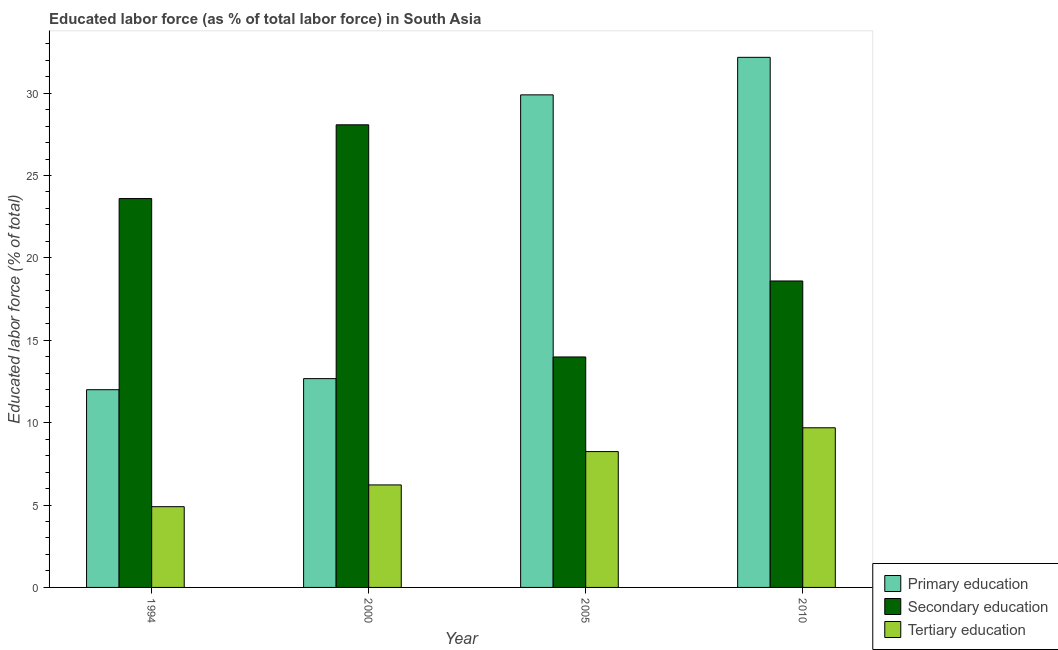How many different coloured bars are there?
Your response must be concise. 3. How many groups of bars are there?
Provide a succinct answer. 4. Are the number of bars per tick equal to the number of legend labels?
Ensure brevity in your answer.  Yes. Are the number of bars on each tick of the X-axis equal?
Your response must be concise. Yes. What is the label of the 4th group of bars from the left?
Ensure brevity in your answer.  2010. What is the percentage of labor force who received secondary education in 1994?
Offer a very short reply. 23.6. Across all years, what is the maximum percentage of labor force who received tertiary education?
Keep it short and to the point. 9.69. Across all years, what is the minimum percentage of labor force who received secondary education?
Provide a succinct answer. 13.99. What is the total percentage of labor force who received secondary education in the graph?
Offer a terse response. 84.26. What is the difference between the percentage of labor force who received primary education in 2005 and that in 2010?
Your response must be concise. -2.28. What is the difference between the percentage of labor force who received primary education in 2010 and the percentage of labor force who received secondary education in 2005?
Provide a short and direct response. 2.28. What is the average percentage of labor force who received tertiary education per year?
Give a very brief answer. 7.26. In how many years, is the percentage of labor force who received tertiary education greater than 30 %?
Provide a succinct answer. 0. What is the ratio of the percentage of labor force who received secondary education in 1994 to that in 2000?
Provide a succinct answer. 0.84. Is the percentage of labor force who received primary education in 1994 less than that in 2000?
Offer a terse response. Yes. What is the difference between the highest and the second highest percentage of labor force who received secondary education?
Give a very brief answer. 4.48. What is the difference between the highest and the lowest percentage of labor force who received secondary education?
Ensure brevity in your answer.  14.09. In how many years, is the percentage of labor force who received primary education greater than the average percentage of labor force who received primary education taken over all years?
Your answer should be very brief. 2. Is the sum of the percentage of labor force who received primary education in 2000 and 2010 greater than the maximum percentage of labor force who received tertiary education across all years?
Your answer should be very brief. Yes. What does the 2nd bar from the left in 2005 represents?
Give a very brief answer. Secondary education. What does the 2nd bar from the right in 2000 represents?
Keep it short and to the point. Secondary education. Is it the case that in every year, the sum of the percentage of labor force who received primary education and percentage of labor force who received secondary education is greater than the percentage of labor force who received tertiary education?
Provide a succinct answer. Yes. How many bars are there?
Give a very brief answer. 12. Does the graph contain grids?
Your answer should be compact. No. What is the title of the graph?
Provide a succinct answer. Educated labor force (as % of total labor force) in South Asia. What is the label or title of the X-axis?
Your response must be concise. Year. What is the label or title of the Y-axis?
Give a very brief answer. Educated labor force (% of total). What is the Educated labor force (% of total) in Secondary education in 1994?
Make the answer very short. 23.6. What is the Educated labor force (% of total) in Tertiary education in 1994?
Your answer should be very brief. 4.9. What is the Educated labor force (% of total) of Primary education in 2000?
Keep it short and to the point. 12.67. What is the Educated labor force (% of total) in Secondary education in 2000?
Your answer should be very brief. 28.08. What is the Educated labor force (% of total) in Tertiary education in 2000?
Offer a very short reply. 6.22. What is the Educated labor force (% of total) in Primary education in 2005?
Your response must be concise. 29.89. What is the Educated labor force (% of total) of Secondary education in 2005?
Provide a succinct answer. 13.99. What is the Educated labor force (% of total) of Tertiary education in 2005?
Offer a very short reply. 8.24. What is the Educated labor force (% of total) of Primary education in 2010?
Your answer should be very brief. 32.17. What is the Educated labor force (% of total) of Secondary education in 2010?
Offer a terse response. 18.6. What is the Educated labor force (% of total) in Tertiary education in 2010?
Your response must be concise. 9.69. Across all years, what is the maximum Educated labor force (% of total) in Primary education?
Provide a succinct answer. 32.17. Across all years, what is the maximum Educated labor force (% of total) in Secondary education?
Provide a short and direct response. 28.08. Across all years, what is the maximum Educated labor force (% of total) of Tertiary education?
Ensure brevity in your answer.  9.69. Across all years, what is the minimum Educated labor force (% of total) of Primary education?
Your answer should be very brief. 12. Across all years, what is the minimum Educated labor force (% of total) of Secondary education?
Your answer should be compact. 13.99. Across all years, what is the minimum Educated labor force (% of total) of Tertiary education?
Your answer should be very brief. 4.9. What is the total Educated labor force (% of total) in Primary education in the graph?
Your answer should be very brief. 86.74. What is the total Educated labor force (% of total) of Secondary education in the graph?
Provide a short and direct response. 84.26. What is the total Educated labor force (% of total) of Tertiary education in the graph?
Offer a very short reply. 29.05. What is the difference between the Educated labor force (% of total) in Primary education in 1994 and that in 2000?
Your answer should be very brief. -0.67. What is the difference between the Educated labor force (% of total) in Secondary education in 1994 and that in 2000?
Your answer should be very brief. -4.48. What is the difference between the Educated labor force (% of total) in Tertiary education in 1994 and that in 2000?
Provide a succinct answer. -1.32. What is the difference between the Educated labor force (% of total) in Primary education in 1994 and that in 2005?
Offer a terse response. -17.89. What is the difference between the Educated labor force (% of total) of Secondary education in 1994 and that in 2005?
Offer a terse response. 9.61. What is the difference between the Educated labor force (% of total) of Tertiary education in 1994 and that in 2005?
Your answer should be compact. -3.34. What is the difference between the Educated labor force (% of total) in Primary education in 1994 and that in 2010?
Provide a short and direct response. -20.17. What is the difference between the Educated labor force (% of total) of Secondary education in 1994 and that in 2010?
Make the answer very short. 5. What is the difference between the Educated labor force (% of total) in Tertiary education in 1994 and that in 2010?
Your answer should be compact. -4.79. What is the difference between the Educated labor force (% of total) of Primary education in 2000 and that in 2005?
Keep it short and to the point. -17.22. What is the difference between the Educated labor force (% of total) of Secondary education in 2000 and that in 2005?
Provide a succinct answer. 14.09. What is the difference between the Educated labor force (% of total) of Tertiary education in 2000 and that in 2005?
Make the answer very short. -2.02. What is the difference between the Educated labor force (% of total) in Primary education in 2000 and that in 2010?
Keep it short and to the point. -19.5. What is the difference between the Educated labor force (% of total) of Secondary education in 2000 and that in 2010?
Your response must be concise. 9.48. What is the difference between the Educated labor force (% of total) of Tertiary education in 2000 and that in 2010?
Provide a succinct answer. -3.47. What is the difference between the Educated labor force (% of total) of Primary education in 2005 and that in 2010?
Provide a short and direct response. -2.28. What is the difference between the Educated labor force (% of total) of Secondary education in 2005 and that in 2010?
Provide a short and direct response. -4.61. What is the difference between the Educated labor force (% of total) of Tertiary education in 2005 and that in 2010?
Make the answer very short. -1.45. What is the difference between the Educated labor force (% of total) in Primary education in 1994 and the Educated labor force (% of total) in Secondary education in 2000?
Your response must be concise. -16.08. What is the difference between the Educated labor force (% of total) of Primary education in 1994 and the Educated labor force (% of total) of Tertiary education in 2000?
Offer a terse response. 5.78. What is the difference between the Educated labor force (% of total) of Secondary education in 1994 and the Educated labor force (% of total) of Tertiary education in 2000?
Offer a very short reply. 17.38. What is the difference between the Educated labor force (% of total) in Primary education in 1994 and the Educated labor force (% of total) in Secondary education in 2005?
Give a very brief answer. -1.99. What is the difference between the Educated labor force (% of total) of Primary education in 1994 and the Educated labor force (% of total) of Tertiary education in 2005?
Your response must be concise. 3.76. What is the difference between the Educated labor force (% of total) in Secondary education in 1994 and the Educated labor force (% of total) in Tertiary education in 2005?
Provide a succinct answer. 15.36. What is the difference between the Educated labor force (% of total) in Primary education in 1994 and the Educated labor force (% of total) in Secondary education in 2010?
Provide a short and direct response. -6.6. What is the difference between the Educated labor force (% of total) of Primary education in 1994 and the Educated labor force (% of total) of Tertiary education in 2010?
Your response must be concise. 2.31. What is the difference between the Educated labor force (% of total) in Secondary education in 1994 and the Educated labor force (% of total) in Tertiary education in 2010?
Keep it short and to the point. 13.91. What is the difference between the Educated labor force (% of total) in Primary education in 2000 and the Educated labor force (% of total) in Secondary education in 2005?
Keep it short and to the point. -1.31. What is the difference between the Educated labor force (% of total) in Primary education in 2000 and the Educated labor force (% of total) in Tertiary education in 2005?
Offer a very short reply. 4.43. What is the difference between the Educated labor force (% of total) of Secondary education in 2000 and the Educated labor force (% of total) of Tertiary education in 2005?
Offer a very short reply. 19.83. What is the difference between the Educated labor force (% of total) in Primary education in 2000 and the Educated labor force (% of total) in Secondary education in 2010?
Offer a very short reply. -5.93. What is the difference between the Educated labor force (% of total) of Primary education in 2000 and the Educated labor force (% of total) of Tertiary education in 2010?
Your answer should be compact. 2.98. What is the difference between the Educated labor force (% of total) in Secondary education in 2000 and the Educated labor force (% of total) in Tertiary education in 2010?
Your answer should be very brief. 18.39. What is the difference between the Educated labor force (% of total) of Primary education in 2005 and the Educated labor force (% of total) of Secondary education in 2010?
Provide a short and direct response. 11.3. What is the difference between the Educated labor force (% of total) of Primary education in 2005 and the Educated labor force (% of total) of Tertiary education in 2010?
Your response must be concise. 20.2. What is the difference between the Educated labor force (% of total) in Secondary education in 2005 and the Educated labor force (% of total) in Tertiary education in 2010?
Make the answer very short. 4.3. What is the average Educated labor force (% of total) of Primary education per year?
Offer a terse response. 21.68. What is the average Educated labor force (% of total) in Secondary education per year?
Provide a short and direct response. 21.06. What is the average Educated labor force (% of total) in Tertiary education per year?
Your response must be concise. 7.26. In the year 1994, what is the difference between the Educated labor force (% of total) of Primary education and Educated labor force (% of total) of Secondary education?
Your response must be concise. -11.6. In the year 1994, what is the difference between the Educated labor force (% of total) of Primary education and Educated labor force (% of total) of Tertiary education?
Keep it short and to the point. 7.1. In the year 1994, what is the difference between the Educated labor force (% of total) of Secondary education and Educated labor force (% of total) of Tertiary education?
Your response must be concise. 18.7. In the year 2000, what is the difference between the Educated labor force (% of total) in Primary education and Educated labor force (% of total) in Secondary education?
Keep it short and to the point. -15.4. In the year 2000, what is the difference between the Educated labor force (% of total) in Primary education and Educated labor force (% of total) in Tertiary education?
Keep it short and to the point. 6.45. In the year 2000, what is the difference between the Educated labor force (% of total) of Secondary education and Educated labor force (% of total) of Tertiary education?
Your response must be concise. 21.85. In the year 2005, what is the difference between the Educated labor force (% of total) of Primary education and Educated labor force (% of total) of Secondary education?
Provide a short and direct response. 15.91. In the year 2005, what is the difference between the Educated labor force (% of total) of Primary education and Educated labor force (% of total) of Tertiary education?
Offer a terse response. 21.65. In the year 2005, what is the difference between the Educated labor force (% of total) of Secondary education and Educated labor force (% of total) of Tertiary education?
Make the answer very short. 5.74. In the year 2010, what is the difference between the Educated labor force (% of total) of Primary education and Educated labor force (% of total) of Secondary education?
Provide a short and direct response. 13.57. In the year 2010, what is the difference between the Educated labor force (% of total) in Primary education and Educated labor force (% of total) in Tertiary education?
Offer a terse response. 22.48. In the year 2010, what is the difference between the Educated labor force (% of total) in Secondary education and Educated labor force (% of total) in Tertiary education?
Offer a very short reply. 8.91. What is the ratio of the Educated labor force (% of total) of Primary education in 1994 to that in 2000?
Give a very brief answer. 0.95. What is the ratio of the Educated labor force (% of total) of Secondary education in 1994 to that in 2000?
Give a very brief answer. 0.84. What is the ratio of the Educated labor force (% of total) in Tertiary education in 1994 to that in 2000?
Your answer should be compact. 0.79. What is the ratio of the Educated labor force (% of total) of Primary education in 1994 to that in 2005?
Keep it short and to the point. 0.4. What is the ratio of the Educated labor force (% of total) in Secondary education in 1994 to that in 2005?
Give a very brief answer. 1.69. What is the ratio of the Educated labor force (% of total) in Tertiary education in 1994 to that in 2005?
Your response must be concise. 0.59. What is the ratio of the Educated labor force (% of total) of Primary education in 1994 to that in 2010?
Provide a short and direct response. 0.37. What is the ratio of the Educated labor force (% of total) in Secondary education in 1994 to that in 2010?
Your response must be concise. 1.27. What is the ratio of the Educated labor force (% of total) in Tertiary education in 1994 to that in 2010?
Provide a succinct answer. 0.51. What is the ratio of the Educated labor force (% of total) in Primary education in 2000 to that in 2005?
Your answer should be compact. 0.42. What is the ratio of the Educated labor force (% of total) in Secondary education in 2000 to that in 2005?
Your response must be concise. 2.01. What is the ratio of the Educated labor force (% of total) in Tertiary education in 2000 to that in 2005?
Provide a short and direct response. 0.75. What is the ratio of the Educated labor force (% of total) in Primary education in 2000 to that in 2010?
Ensure brevity in your answer.  0.39. What is the ratio of the Educated labor force (% of total) of Secondary education in 2000 to that in 2010?
Your answer should be compact. 1.51. What is the ratio of the Educated labor force (% of total) of Tertiary education in 2000 to that in 2010?
Give a very brief answer. 0.64. What is the ratio of the Educated labor force (% of total) of Primary education in 2005 to that in 2010?
Offer a terse response. 0.93. What is the ratio of the Educated labor force (% of total) of Secondary education in 2005 to that in 2010?
Your response must be concise. 0.75. What is the ratio of the Educated labor force (% of total) of Tertiary education in 2005 to that in 2010?
Offer a very short reply. 0.85. What is the difference between the highest and the second highest Educated labor force (% of total) in Primary education?
Provide a succinct answer. 2.28. What is the difference between the highest and the second highest Educated labor force (% of total) in Secondary education?
Offer a terse response. 4.48. What is the difference between the highest and the second highest Educated labor force (% of total) of Tertiary education?
Give a very brief answer. 1.45. What is the difference between the highest and the lowest Educated labor force (% of total) in Primary education?
Offer a very short reply. 20.17. What is the difference between the highest and the lowest Educated labor force (% of total) in Secondary education?
Ensure brevity in your answer.  14.09. What is the difference between the highest and the lowest Educated labor force (% of total) of Tertiary education?
Give a very brief answer. 4.79. 